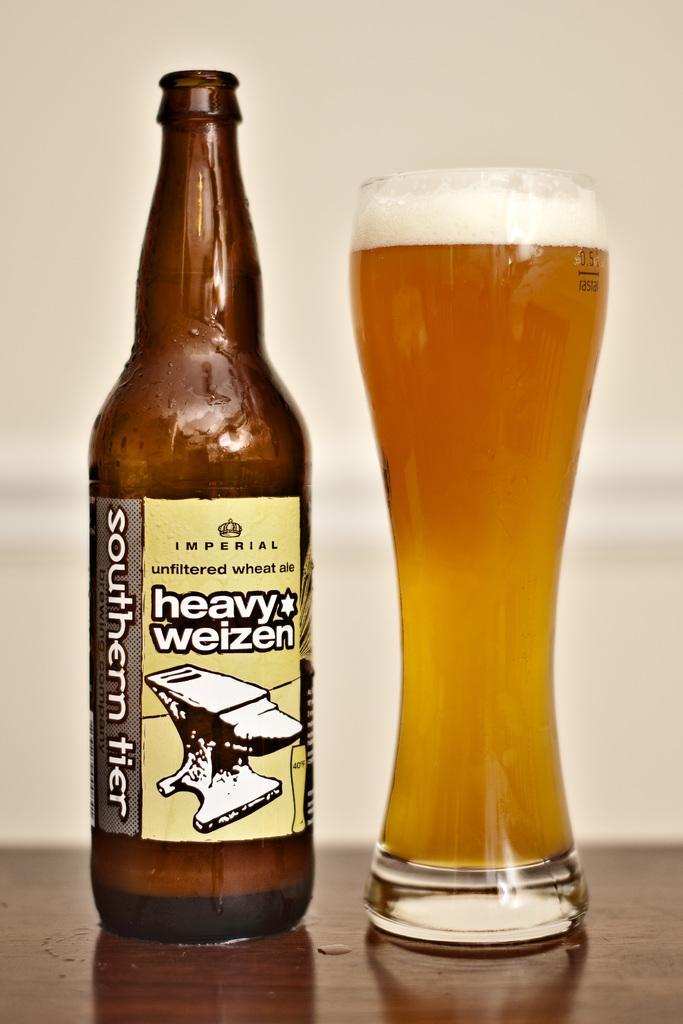Could you give a brief overview of what you see in this image? In this image I can see a beer bottle with a label attached to it. And this is a beer glass with glass full of beer which are placed on the table. 